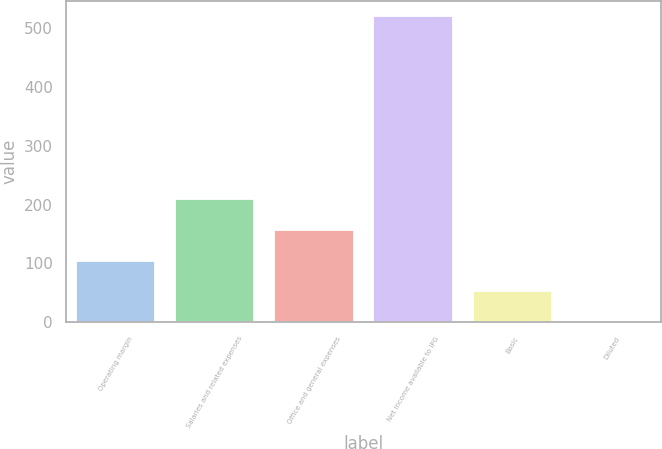Convert chart. <chart><loc_0><loc_0><loc_500><loc_500><bar_chart><fcel>Operating margin<fcel>Salaries and related expenses<fcel>Office and general expenses<fcel>Net income available to IPG<fcel>Basic<fcel>Diluted<nl><fcel>104.93<fcel>208.87<fcel>156.9<fcel>520.7<fcel>52.96<fcel>0.99<nl></chart> 